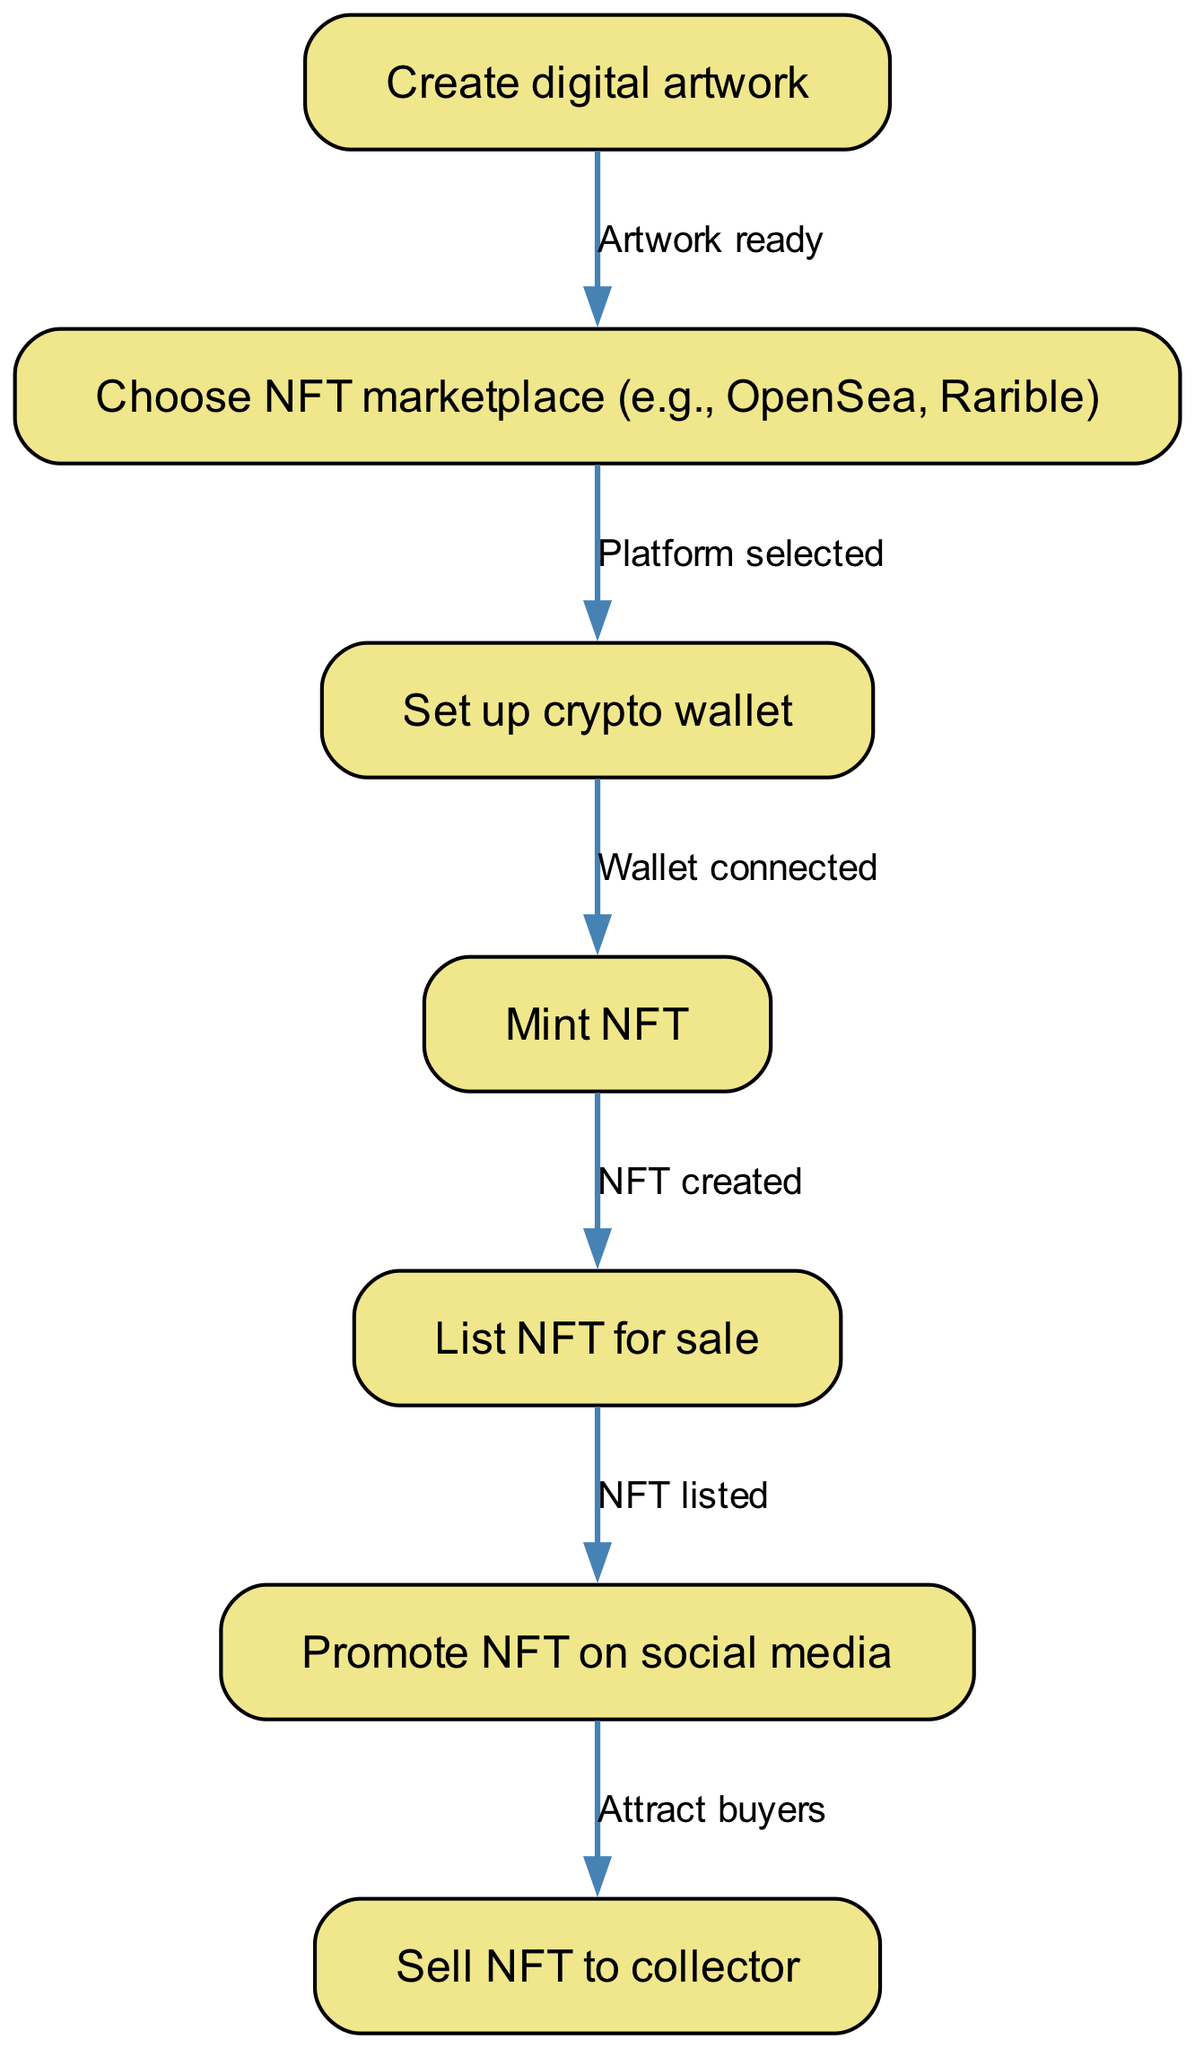What is the first step in creating and selling digital art NFTs? The first step in the process is to "Create digital artwork," which is indicated as the starting node in the diagram.
Answer: Create digital artwork How many nodes are present in the flow chart? The diagram lists a total of seven nodes, representing different stages of the NFT creation and sale process.
Answer: Seven What action follows choosing an NFT marketplace? After choosing an NFT marketplace, the next action is to "Set up crypto wallet," which is connected by an edge from the marketplace node.
Answer: Set up crypto wallet What connects "Mint NFT" to "List NFT for sale"? The connection is established by the edge labeled "NFT created," which indicates that the minting process must be completed before listing the NFT for sale.
Answer: NFT created Which node follows "Promote NFT on social media"? The node that follows is "Sell NFT to collector," signifying that promoting the NFT is essential for attracting buyers leading to the sale.
Answer: Sell NFT to collector What is the relationship between "Create digital artwork" and "Choose NFT marketplace"? The relationship is that "Artwork ready" connects these two nodes, indicating that once the artwork is ready, the next step is to choose the NFT marketplace.
Answer: Artwork ready How does the process flow from setting up a crypto wallet to minting an NFT? After setting up the crypto wallet, which requires the platform to be selected, the next step is to "Mint NFT." This shows that the wallet must be connected before minting can occur.
Answer: Mint NFT What is the final outcome of the flow chart? The final outcome of the flow chart is "Sell NFT to collector," which signifies the ultimate goal of the entire process.
Answer: Sell NFT to collector 